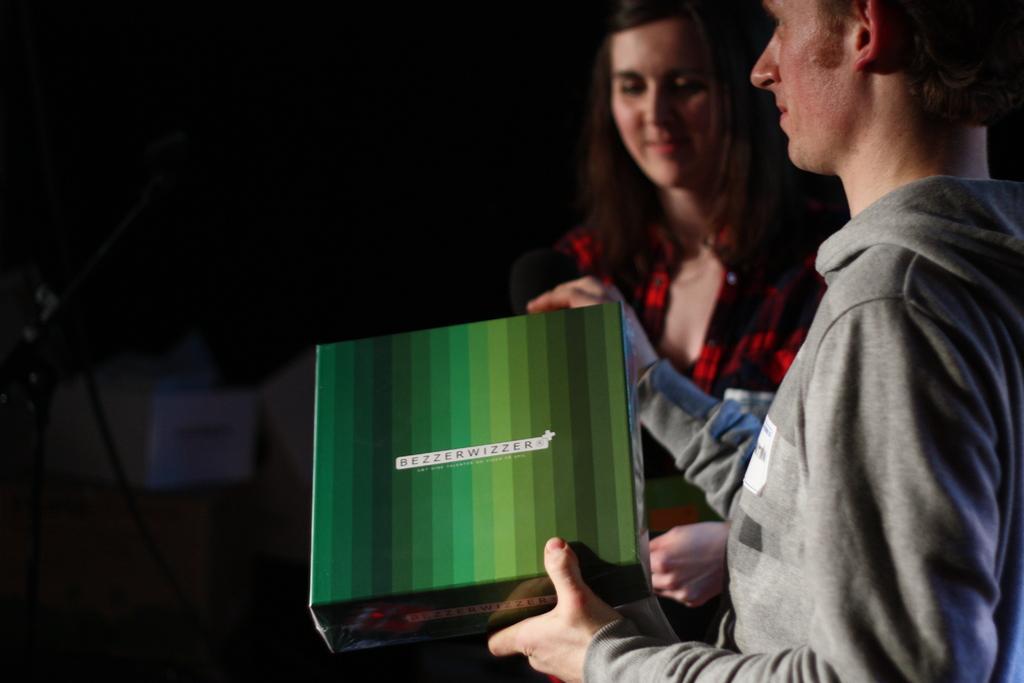Describe this image in one or two sentences. In this image in the front there is a person standing and holding a box which is green in colour with some text written on it and in the background there is a woman standing and smiling. On the left side there is an object which is black in colour which is visible. 